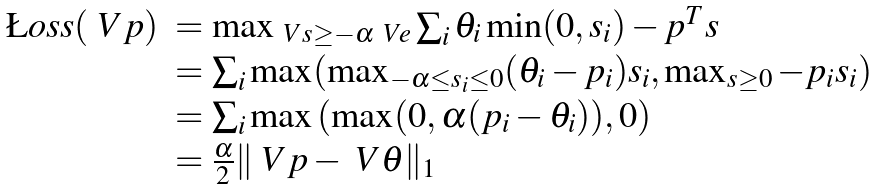Convert formula to latex. <formula><loc_0><loc_0><loc_500><loc_500>\begin{array} { l l } \L o s s ( \ V { p } ) & = \max _ { \ V { s } \geq - \alpha \ V { e } } \sum _ { i } \theta _ { i } \min ( 0 , s _ { i } ) - p ^ { T } s \\ & = \sum _ { i } \max ( \max _ { - \alpha \leq s _ { i } \leq 0 } ( \theta _ { i } - p _ { i } ) s _ { i } , \max _ { s \geq 0 } - p _ { i } s _ { i } ) \\ & = \sum _ { i } \max \left ( \max ( 0 , \alpha ( p _ { i } - \theta _ { i } ) ) , 0 \right ) \\ & = \frac { \alpha } { 2 } \| \ V { p } - \ V { \theta } \| _ { 1 } \\ \end{array}</formula> 